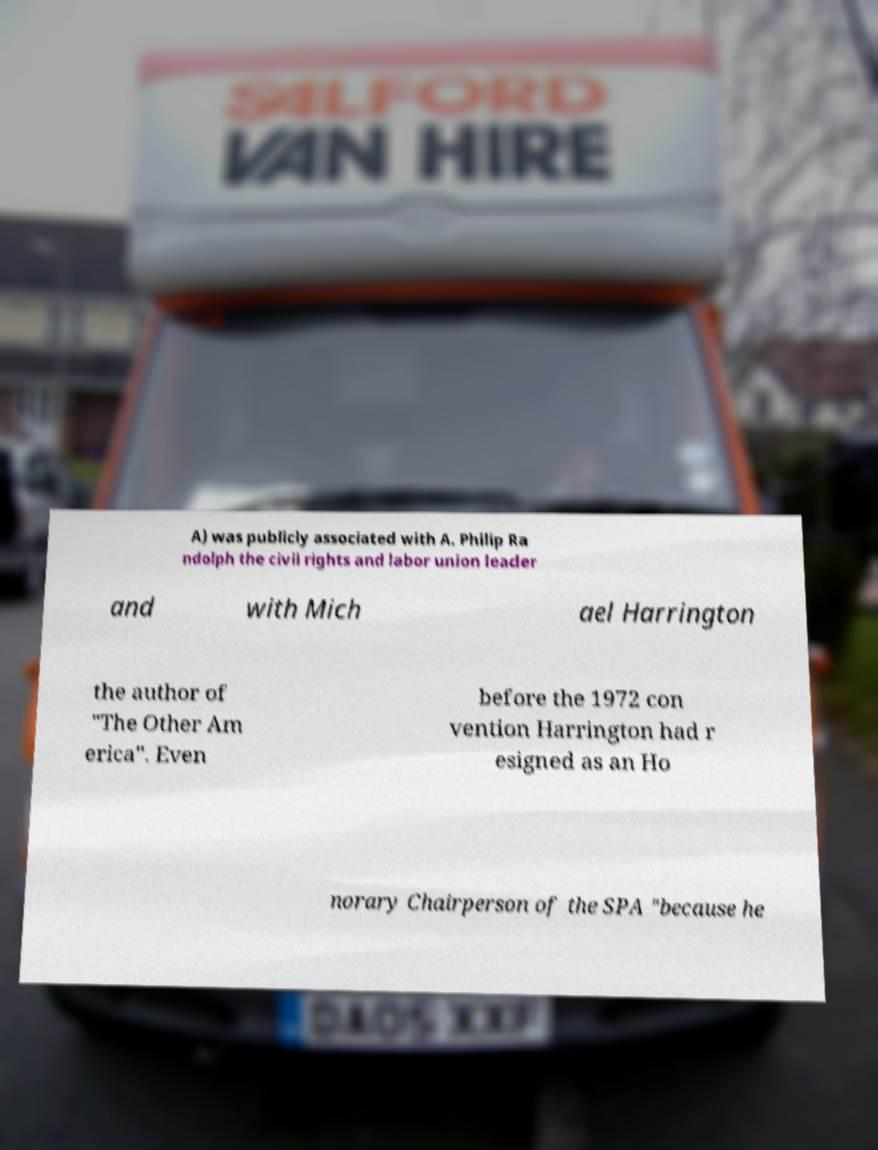Can you read and provide the text displayed in the image?This photo seems to have some interesting text. Can you extract and type it out for me? A) was publicly associated with A. Philip Ra ndolph the civil rights and labor union leader and with Mich ael Harrington the author of "The Other Am erica". Even before the 1972 con vention Harrington had r esigned as an Ho norary Chairperson of the SPA "because he 